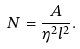Convert formula to latex. <formula><loc_0><loc_0><loc_500><loc_500>N = \frac { A } { \eta ^ { 2 } l ^ { 2 } } .</formula> 